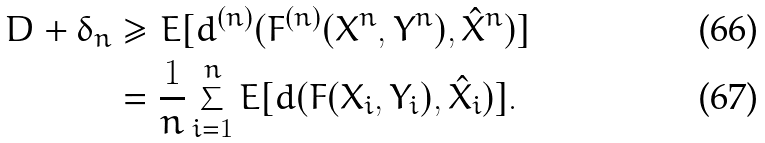<formula> <loc_0><loc_0><loc_500><loc_500>D + \delta _ { n } & \geq E [ d ^ { ( n ) } ( F ^ { ( n ) } ( X ^ { n } , Y ^ { n } ) , \hat { X } ^ { n } ) ] \\ & = \frac { 1 } { n } \sum _ { i = 1 } ^ { n } E [ d ( F ( X _ { i } , Y _ { i } ) , \hat { X } _ { i } ) ] .</formula> 